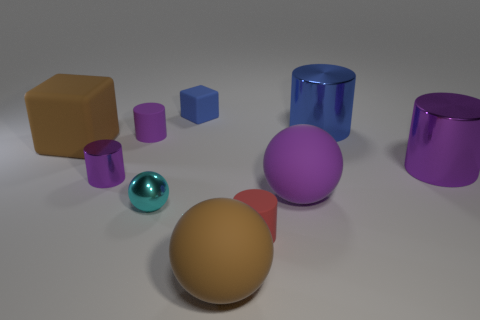There is a large metal thing that is in front of the blue metallic cylinder; does it have the same shape as the purple metal thing that is in front of the large purple cylinder?
Provide a short and direct response. Yes. There is a large block that is made of the same material as the tiny cube; what color is it?
Your answer should be very brief. Brown. There is a brown object to the left of the large brown rubber sphere; does it have the same size as the cylinder right of the big blue cylinder?
Your response must be concise. Yes. What is the shape of the metal object that is both on the left side of the red thing and behind the cyan shiny ball?
Provide a succinct answer. Cylinder. Are there any other blue blocks made of the same material as the tiny cube?
Your answer should be compact. No. There is a ball that is the same color as the big matte cube; what material is it?
Make the answer very short. Rubber. Are the purple cylinder to the right of the cyan metal sphere and the small purple thing that is in front of the purple matte cylinder made of the same material?
Provide a short and direct response. Yes. Is the number of brown balls greater than the number of tiny green metallic cylinders?
Your answer should be very brief. Yes. What is the color of the shiny object on the left side of the small purple cylinder that is behind the purple shiny object that is on the left side of the small metallic sphere?
Your response must be concise. Purple. There is a small matte cylinder that is on the left side of the large brown sphere; does it have the same color as the big cylinder in front of the blue shiny thing?
Your answer should be very brief. Yes. 